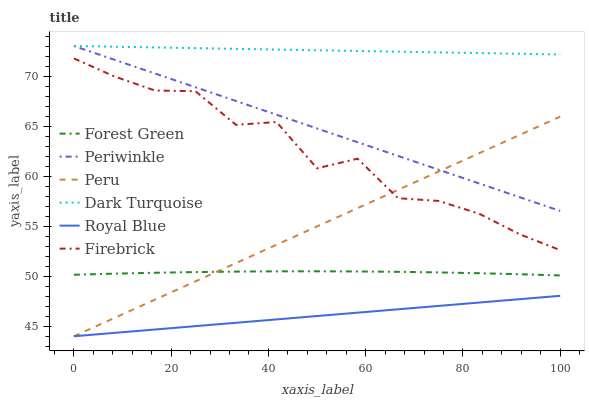Does Royal Blue have the minimum area under the curve?
Answer yes or no. Yes. Does Dark Turquoise have the maximum area under the curve?
Answer yes or no. Yes. Does Firebrick have the minimum area under the curve?
Answer yes or no. No. Does Firebrick have the maximum area under the curve?
Answer yes or no. No. Is Peru the smoothest?
Answer yes or no. Yes. Is Firebrick the roughest?
Answer yes or no. Yes. Is Royal Blue the smoothest?
Answer yes or no. No. Is Royal Blue the roughest?
Answer yes or no. No. Does Royal Blue have the lowest value?
Answer yes or no. Yes. Does Firebrick have the lowest value?
Answer yes or no. No. Does Periwinkle have the highest value?
Answer yes or no. Yes. Does Firebrick have the highest value?
Answer yes or no. No. Is Royal Blue less than Forest Green?
Answer yes or no. Yes. Is Firebrick greater than Royal Blue?
Answer yes or no. Yes. Does Royal Blue intersect Peru?
Answer yes or no. Yes. Is Royal Blue less than Peru?
Answer yes or no. No. Is Royal Blue greater than Peru?
Answer yes or no. No. Does Royal Blue intersect Forest Green?
Answer yes or no. No. 